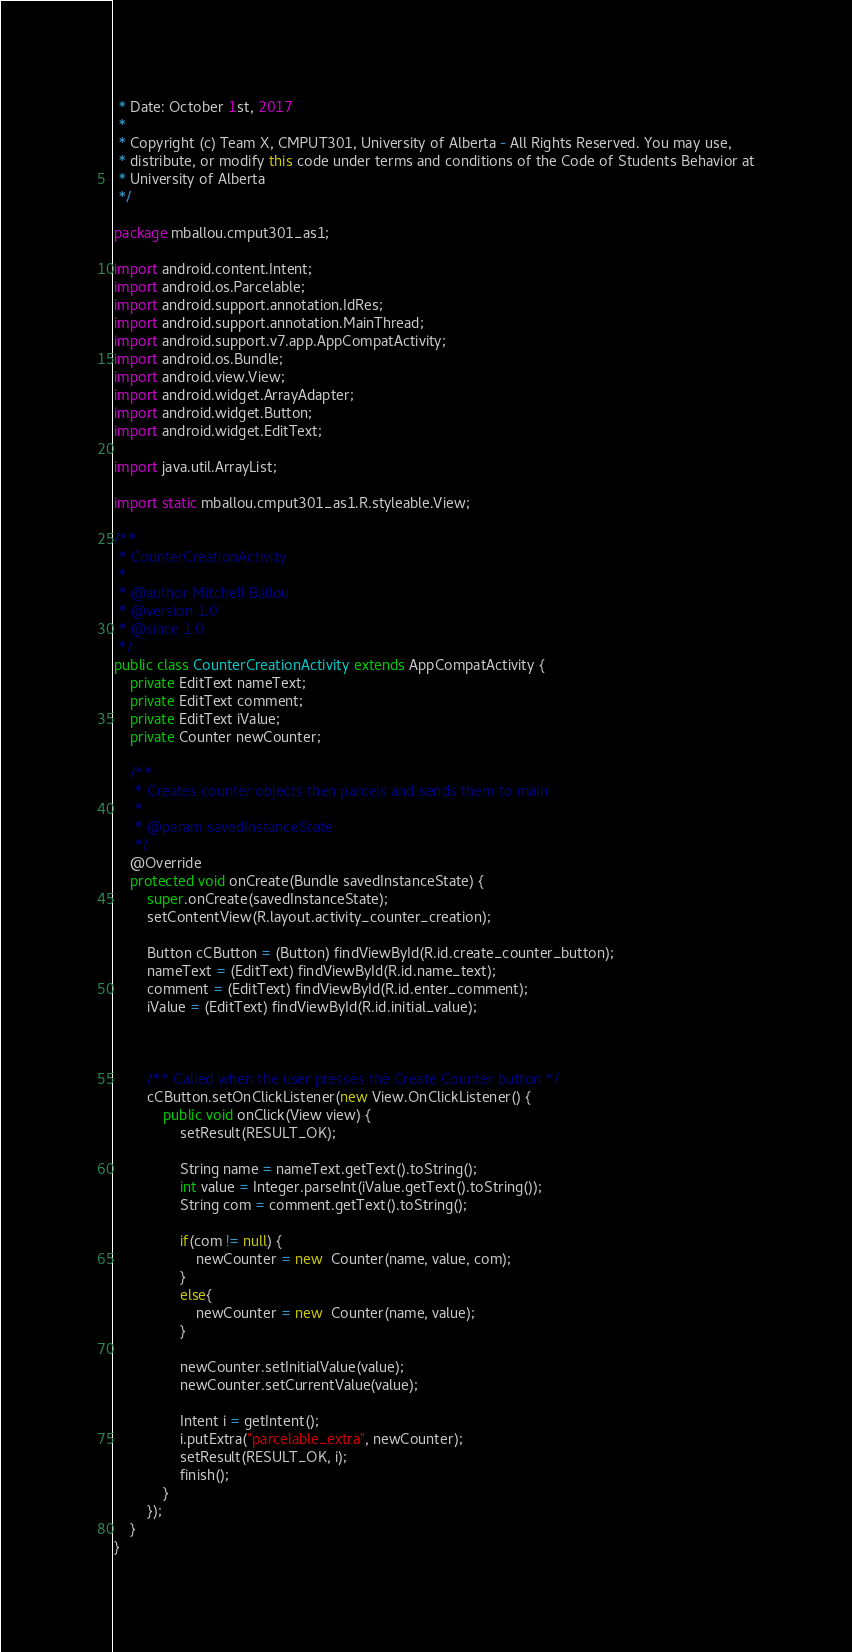<code> <loc_0><loc_0><loc_500><loc_500><_Java_> * Date: October 1st, 2017
 *
 * Copyright (c) Team X, CMPUT301, University of Alberta - All Rights Reserved. You may use,
 * distribute, or modify this code under terms and conditions of the Code of Students Behavior at
 * University of Alberta
 */

package mballou.cmput301_as1;

import android.content.Intent;
import android.os.Parcelable;
import android.support.annotation.IdRes;
import android.support.annotation.MainThread;
import android.support.v7.app.AppCompatActivity;
import android.os.Bundle;
import android.view.View;
import android.widget.ArrayAdapter;
import android.widget.Button;
import android.widget.EditText;

import java.util.ArrayList;

import static mballou.cmput301_as1.R.styleable.View;

/**
 * CounterCreationActivity
 *
 * @author Mitchell Ballou
 * @version 1.0
 * @since 1.0
 */
public class CounterCreationActivity extends AppCompatActivity {
    private EditText nameText;
    private EditText comment;
    private EditText iValue;
    private Counter newCounter;

    /**
     * Creates counter objects then parcels and sends them to main
     *
     * @param savedInstanceState
     */
    @Override
    protected void onCreate(Bundle savedInstanceState) {
        super.onCreate(savedInstanceState);
        setContentView(R.layout.activity_counter_creation);

        Button cCButton = (Button) findViewById(R.id.create_counter_button);
        nameText = (EditText) findViewById(R.id.name_text);
        comment = (EditText) findViewById(R.id.enter_comment);
        iValue = (EditText) findViewById(R.id.initial_value);



        /** Called when the user presses the Create Counter button */
        cCButton.setOnClickListener(new View.OnClickListener() {
            public void onClick(View view) {
                setResult(RESULT_OK);

                String name = nameText.getText().toString();
                int value = Integer.parseInt(iValue.getText().toString());
                String com = comment.getText().toString();

                if(com != null) {
                    newCounter = new  Counter(name, value, com);
                }
                else{
                    newCounter = new  Counter(name, value);
                }

                newCounter.setInitialValue(value);
                newCounter.setCurrentValue(value);

                Intent i = getIntent();
                i.putExtra("parcelable_extra", newCounter);
                setResult(RESULT_OK, i);
                finish();
            }
        });
    }
}</code> 